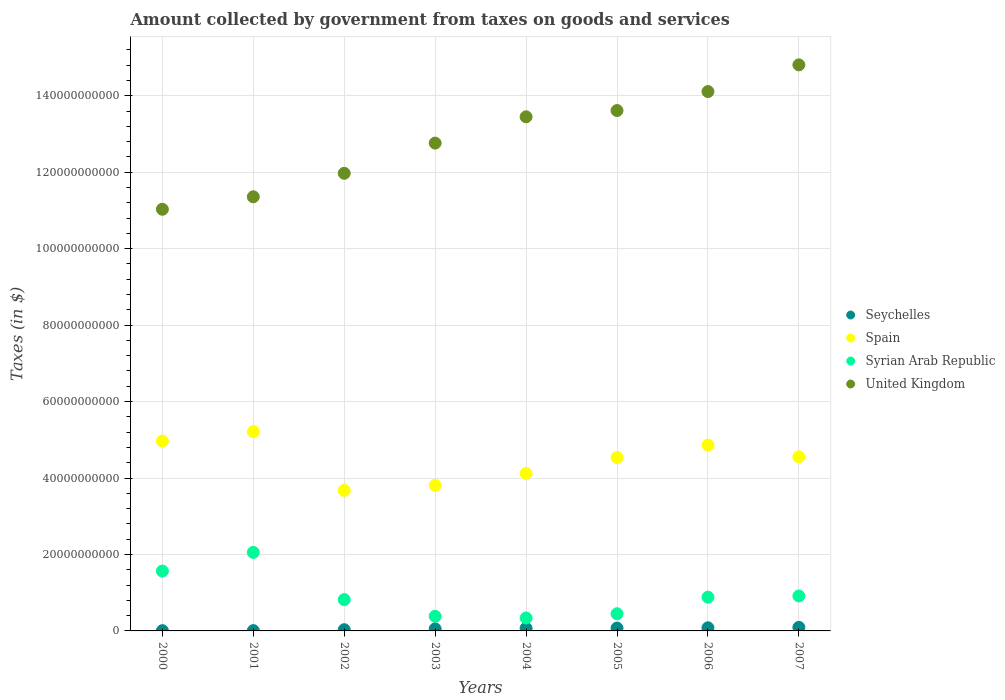How many different coloured dotlines are there?
Your answer should be compact. 4. Is the number of dotlines equal to the number of legend labels?
Offer a very short reply. Yes. What is the amount collected by government from taxes on goods and services in United Kingdom in 2005?
Keep it short and to the point. 1.36e+11. Across all years, what is the maximum amount collected by government from taxes on goods and services in Seychelles?
Your answer should be very brief. 9.26e+08. Across all years, what is the minimum amount collected by government from taxes on goods and services in United Kingdom?
Offer a very short reply. 1.10e+11. In which year was the amount collected by government from taxes on goods and services in United Kingdom maximum?
Your answer should be very brief. 2007. In which year was the amount collected by government from taxes on goods and services in Seychelles minimum?
Offer a terse response. 2000. What is the total amount collected by government from taxes on goods and services in Syrian Arab Republic in the graph?
Make the answer very short. 7.41e+1. What is the difference between the amount collected by government from taxes on goods and services in Spain in 2004 and that in 2006?
Offer a terse response. -7.43e+09. What is the difference between the amount collected by government from taxes on goods and services in Spain in 2005 and the amount collected by government from taxes on goods and services in Seychelles in 2001?
Your response must be concise. 4.53e+1. What is the average amount collected by government from taxes on goods and services in Spain per year?
Make the answer very short. 4.47e+1. In the year 2000, what is the difference between the amount collected by government from taxes on goods and services in Syrian Arab Republic and amount collected by government from taxes on goods and services in Spain?
Provide a succinct answer. -3.40e+1. In how many years, is the amount collected by government from taxes on goods and services in Spain greater than 20000000000 $?
Provide a succinct answer. 8. What is the ratio of the amount collected by government from taxes on goods and services in United Kingdom in 2000 to that in 2002?
Keep it short and to the point. 0.92. Is the amount collected by government from taxes on goods and services in United Kingdom in 2001 less than that in 2007?
Provide a short and direct response. Yes. Is the difference between the amount collected by government from taxes on goods and services in Syrian Arab Republic in 2001 and 2004 greater than the difference between the amount collected by government from taxes on goods and services in Spain in 2001 and 2004?
Make the answer very short. Yes. What is the difference between the highest and the second highest amount collected by government from taxes on goods and services in United Kingdom?
Your response must be concise. 6.98e+09. What is the difference between the highest and the lowest amount collected by government from taxes on goods and services in Seychelles?
Offer a terse response. 8.55e+08. Is it the case that in every year, the sum of the amount collected by government from taxes on goods and services in Seychelles and amount collected by government from taxes on goods and services in Syrian Arab Republic  is greater than the sum of amount collected by government from taxes on goods and services in Spain and amount collected by government from taxes on goods and services in United Kingdom?
Your answer should be very brief. No. Is it the case that in every year, the sum of the amount collected by government from taxes on goods and services in Seychelles and amount collected by government from taxes on goods and services in Spain  is greater than the amount collected by government from taxes on goods and services in United Kingdom?
Ensure brevity in your answer.  No. Does the amount collected by government from taxes on goods and services in Seychelles monotonically increase over the years?
Provide a succinct answer. Yes. Is the amount collected by government from taxes on goods and services in United Kingdom strictly greater than the amount collected by government from taxes on goods and services in Seychelles over the years?
Your answer should be compact. Yes. Is the amount collected by government from taxes on goods and services in Seychelles strictly less than the amount collected by government from taxes on goods and services in United Kingdom over the years?
Ensure brevity in your answer.  Yes. How many years are there in the graph?
Provide a short and direct response. 8. Are the values on the major ticks of Y-axis written in scientific E-notation?
Your answer should be very brief. No. Does the graph contain any zero values?
Offer a terse response. No. Does the graph contain grids?
Keep it short and to the point. Yes. How many legend labels are there?
Your answer should be compact. 4. How are the legend labels stacked?
Offer a terse response. Vertical. What is the title of the graph?
Give a very brief answer. Amount collected by government from taxes on goods and services. What is the label or title of the Y-axis?
Offer a terse response. Taxes (in $). What is the Taxes (in $) of Seychelles in 2000?
Provide a short and direct response. 7.17e+07. What is the Taxes (in $) of Spain in 2000?
Keep it short and to the point. 4.97e+1. What is the Taxes (in $) of Syrian Arab Republic in 2000?
Make the answer very short. 1.57e+1. What is the Taxes (in $) of United Kingdom in 2000?
Your answer should be compact. 1.10e+11. What is the Taxes (in $) of Seychelles in 2001?
Give a very brief answer. 8.16e+07. What is the Taxes (in $) in Spain in 2001?
Offer a terse response. 5.21e+1. What is the Taxes (in $) of Syrian Arab Republic in 2001?
Give a very brief answer. 2.05e+1. What is the Taxes (in $) of United Kingdom in 2001?
Provide a short and direct response. 1.14e+11. What is the Taxes (in $) of Seychelles in 2002?
Provide a succinct answer. 3.22e+08. What is the Taxes (in $) of Spain in 2002?
Keep it short and to the point. 3.68e+1. What is the Taxes (in $) in Syrian Arab Republic in 2002?
Make the answer very short. 8.19e+09. What is the Taxes (in $) in United Kingdom in 2002?
Your answer should be very brief. 1.20e+11. What is the Taxes (in $) in Seychelles in 2003?
Ensure brevity in your answer.  5.47e+08. What is the Taxes (in $) of Spain in 2003?
Provide a short and direct response. 3.81e+1. What is the Taxes (in $) in Syrian Arab Republic in 2003?
Your answer should be very brief. 3.82e+09. What is the Taxes (in $) in United Kingdom in 2003?
Your answer should be compact. 1.28e+11. What is the Taxes (in $) of Seychelles in 2004?
Keep it short and to the point. 6.87e+08. What is the Taxes (in $) of Spain in 2004?
Your response must be concise. 4.12e+1. What is the Taxes (in $) of Syrian Arab Republic in 2004?
Your response must be concise. 3.38e+09. What is the Taxes (in $) in United Kingdom in 2004?
Your answer should be compact. 1.34e+11. What is the Taxes (in $) in Seychelles in 2005?
Provide a short and direct response. 7.52e+08. What is the Taxes (in $) of Spain in 2005?
Make the answer very short. 4.54e+1. What is the Taxes (in $) of Syrian Arab Republic in 2005?
Your answer should be very brief. 4.49e+09. What is the Taxes (in $) in United Kingdom in 2005?
Offer a very short reply. 1.36e+11. What is the Taxes (in $) in Seychelles in 2006?
Keep it short and to the point. 8.21e+08. What is the Taxes (in $) of Spain in 2006?
Ensure brevity in your answer.  4.86e+1. What is the Taxes (in $) in Syrian Arab Republic in 2006?
Your answer should be very brief. 8.83e+09. What is the Taxes (in $) in United Kingdom in 2006?
Your answer should be very brief. 1.41e+11. What is the Taxes (in $) of Seychelles in 2007?
Provide a short and direct response. 9.26e+08. What is the Taxes (in $) of Spain in 2007?
Your answer should be compact. 4.55e+1. What is the Taxes (in $) of Syrian Arab Republic in 2007?
Make the answer very short. 9.14e+09. What is the Taxes (in $) in United Kingdom in 2007?
Provide a short and direct response. 1.48e+11. Across all years, what is the maximum Taxes (in $) in Seychelles?
Ensure brevity in your answer.  9.26e+08. Across all years, what is the maximum Taxes (in $) of Spain?
Your answer should be compact. 5.21e+1. Across all years, what is the maximum Taxes (in $) in Syrian Arab Republic?
Your answer should be compact. 2.05e+1. Across all years, what is the maximum Taxes (in $) of United Kingdom?
Give a very brief answer. 1.48e+11. Across all years, what is the minimum Taxes (in $) in Seychelles?
Your response must be concise. 7.17e+07. Across all years, what is the minimum Taxes (in $) in Spain?
Your answer should be compact. 3.68e+1. Across all years, what is the minimum Taxes (in $) in Syrian Arab Republic?
Offer a very short reply. 3.38e+09. Across all years, what is the minimum Taxes (in $) in United Kingdom?
Make the answer very short. 1.10e+11. What is the total Taxes (in $) in Seychelles in the graph?
Your answer should be compact. 4.21e+09. What is the total Taxes (in $) of Spain in the graph?
Make the answer very short. 3.57e+11. What is the total Taxes (in $) of Syrian Arab Republic in the graph?
Offer a terse response. 7.41e+1. What is the total Taxes (in $) of United Kingdom in the graph?
Your response must be concise. 1.03e+12. What is the difference between the Taxes (in $) in Seychelles in 2000 and that in 2001?
Provide a short and direct response. -9.90e+06. What is the difference between the Taxes (in $) of Spain in 2000 and that in 2001?
Offer a very short reply. -2.46e+09. What is the difference between the Taxes (in $) of Syrian Arab Republic in 2000 and that in 2001?
Provide a short and direct response. -4.89e+09. What is the difference between the Taxes (in $) of United Kingdom in 2000 and that in 2001?
Provide a succinct answer. -3.27e+09. What is the difference between the Taxes (in $) of Seychelles in 2000 and that in 2002?
Give a very brief answer. -2.50e+08. What is the difference between the Taxes (in $) in Spain in 2000 and that in 2002?
Offer a terse response. 1.29e+1. What is the difference between the Taxes (in $) in Syrian Arab Republic in 2000 and that in 2002?
Ensure brevity in your answer.  7.46e+09. What is the difference between the Taxes (in $) of United Kingdom in 2000 and that in 2002?
Your answer should be very brief. -9.41e+09. What is the difference between the Taxes (in $) of Seychelles in 2000 and that in 2003?
Offer a terse response. -4.75e+08. What is the difference between the Taxes (in $) in Spain in 2000 and that in 2003?
Offer a very short reply. 1.16e+1. What is the difference between the Taxes (in $) in Syrian Arab Republic in 2000 and that in 2003?
Provide a succinct answer. 1.18e+1. What is the difference between the Taxes (in $) of United Kingdom in 2000 and that in 2003?
Ensure brevity in your answer.  -1.73e+1. What is the difference between the Taxes (in $) in Seychelles in 2000 and that in 2004?
Make the answer very short. -6.15e+08. What is the difference between the Taxes (in $) of Spain in 2000 and that in 2004?
Your answer should be compact. 8.47e+09. What is the difference between the Taxes (in $) of Syrian Arab Republic in 2000 and that in 2004?
Your answer should be compact. 1.23e+1. What is the difference between the Taxes (in $) of United Kingdom in 2000 and that in 2004?
Your answer should be very brief. -2.42e+1. What is the difference between the Taxes (in $) in Seychelles in 2000 and that in 2005?
Your answer should be compact. -6.80e+08. What is the difference between the Taxes (in $) of Spain in 2000 and that in 2005?
Offer a very short reply. 4.29e+09. What is the difference between the Taxes (in $) in Syrian Arab Republic in 2000 and that in 2005?
Offer a terse response. 1.12e+1. What is the difference between the Taxes (in $) in United Kingdom in 2000 and that in 2005?
Make the answer very short. -2.58e+1. What is the difference between the Taxes (in $) in Seychelles in 2000 and that in 2006?
Make the answer very short. -7.49e+08. What is the difference between the Taxes (in $) in Spain in 2000 and that in 2006?
Provide a short and direct response. 1.04e+09. What is the difference between the Taxes (in $) in Syrian Arab Republic in 2000 and that in 2006?
Give a very brief answer. 6.82e+09. What is the difference between the Taxes (in $) in United Kingdom in 2000 and that in 2006?
Provide a succinct answer. -3.08e+1. What is the difference between the Taxes (in $) of Seychelles in 2000 and that in 2007?
Keep it short and to the point. -8.55e+08. What is the difference between the Taxes (in $) of Spain in 2000 and that in 2007?
Give a very brief answer. 4.12e+09. What is the difference between the Taxes (in $) of Syrian Arab Republic in 2000 and that in 2007?
Keep it short and to the point. 6.51e+09. What is the difference between the Taxes (in $) in United Kingdom in 2000 and that in 2007?
Ensure brevity in your answer.  -3.78e+1. What is the difference between the Taxes (in $) in Seychelles in 2001 and that in 2002?
Offer a terse response. -2.40e+08. What is the difference between the Taxes (in $) of Spain in 2001 and that in 2002?
Your response must be concise. 1.54e+1. What is the difference between the Taxes (in $) of Syrian Arab Republic in 2001 and that in 2002?
Make the answer very short. 1.24e+1. What is the difference between the Taxes (in $) in United Kingdom in 2001 and that in 2002?
Provide a succinct answer. -6.14e+09. What is the difference between the Taxes (in $) of Seychelles in 2001 and that in 2003?
Your answer should be very brief. -4.66e+08. What is the difference between the Taxes (in $) in Spain in 2001 and that in 2003?
Your answer should be very brief. 1.40e+1. What is the difference between the Taxes (in $) in Syrian Arab Republic in 2001 and that in 2003?
Offer a very short reply. 1.67e+1. What is the difference between the Taxes (in $) of United Kingdom in 2001 and that in 2003?
Offer a terse response. -1.40e+1. What is the difference between the Taxes (in $) in Seychelles in 2001 and that in 2004?
Your answer should be compact. -6.05e+08. What is the difference between the Taxes (in $) of Spain in 2001 and that in 2004?
Offer a terse response. 1.09e+1. What is the difference between the Taxes (in $) in Syrian Arab Republic in 2001 and that in 2004?
Make the answer very short. 1.72e+1. What is the difference between the Taxes (in $) in United Kingdom in 2001 and that in 2004?
Ensure brevity in your answer.  -2.09e+1. What is the difference between the Taxes (in $) of Seychelles in 2001 and that in 2005?
Your answer should be compact. -6.70e+08. What is the difference between the Taxes (in $) of Spain in 2001 and that in 2005?
Keep it short and to the point. 6.75e+09. What is the difference between the Taxes (in $) of Syrian Arab Republic in 2001 and that in 2005?
Your answer should be very brief. 1.61e+1. What is the difference between the Taxes (in $) of United Kingdom in 2001 and that in 2005?
Make the answer very short. -2.26e+1. What is the difference between the Taxes (in $) in Seychelles in 2001 and that in 2006?
Offer a very short reply. -7.39e+08. What is the difference between the Taxes (in $) of Spain in 2001 and that in 2006?
Your answer should be compact. 3.50e+09. What is the difference between the Taxes (in $) in Syrian Arab Republic in 2001 and that in 2006?
Make the answer very short. 1.17e+1. What is the difference between the Taxes (in $) in United Kingdom in 2001 and that in 2006?
Provide a short and direct response. -2.75e+1. What is the difference between the Taxes (in $) in Seychelles in 2001 and that in 2007?
Offer a terse response. -8.45e+08. What is the difference between the Taxes (in $) in Spain in 2001 and that in 2007?
Your response must be concise. 6.58e+09. What is the difference between the Taxes (in $) in Syrian Arab Republic in 2001 and that in 2007?
Offer a very short reply. 1.14e+1. What is the difference between the Taxes (in $) in United Kingdom in 2001 and that in 2007?
Provide a succinct answer. -3.45e+1. What is the difference between the Taxes (in $) of Seychelles in 2002 and that in 2003?
Offer a terse response. -2.26e+08. What is the difference between the Taxes (in $) in Spain in 2002 and that in 2003?
Offer a terse response. -1.32e+09. What is the difference between the Taxes (in $) in Syrian Arab Republic in 2002 and that in 2003?
Offer a very short reply. 4.37e+09. What is the difference between the Taxes (in $) of United Kingdom in 2002 and that in 2003?
Keep it short and to the point. -7.90e+09. What is the difference between the Taxes (in $) of Seychelles in 2002 and that in 2004?
Provide a short and direct response. -3.65e+08. What is the difference between the Taxes (in $) in Spain in 2002 and that in 2004?
Make the answer very short. -4.43e+09. What is the difference between the Taxes (in $) of Syrian Arab Republic in 2002 and that in 2004?
Offer a very short reply. 4.81e+09. What is the difference between the Taxes (in $) of United Kingdom in 2002 and that in 2004?
Offer a very short reply. -1.48e+1. What is the difference between the Taxes (in $) of Seychelles in 2002 and that in 2005?
Make the answer very short. -4.30e+08. What is the difference between the Taxes (in $) of Spain in 2002 and that in 2005?
Provide a succinct answer. -8.61e+09. What is the difference between the Taxes (in $) in Syrian Arab Republic in 2002 and that in 2005?
Offer a terse response. 3.70e+09. What is the difference between the Taxes (in $) in United Kingdom in 2002 and that in 2005?
Make the answer very short. -1.64e+1. What is the difference between the Taxes (in $) in Seychelles in 2002 and that in 2006?
Ensure brevity in your answer.  -4.99e+08. What is the difference between the Taxes (in $) in Spain in 2002 and that in 2006?
Provide a succinct answer. -1.19e+1. What is the difference between the Taxes (in $) of Syrian Arab Republic in 2002 and that in 2006?
Your answer should be compact. -6.39e+08. What is the difference between the Taxes (in $) of United Kingdom in 2002 and that in 2006?
Keep it short and to the point. -2.14e+1. What is the difference between the Taxes (in $) in Seychelles in 2002 and that in 2007?
Ensure brevity in your answer.  -6.05e+08. What is the difference between the Taxes (in $) of Spain in 2002 and that in 2007?
Offer a terse response. -8.78e+09. What is the difference between the Taxes (in $) in Syrian Arab Republic in 2002 and that in 2007?
Make the answer very short. -9.52e+08. What is the difference between the Taxes (in $) in United Kingdom in 2002 and that in 2007?
Provide a short and direct response. -2.84e+1. What is the difference between the Taxes (in $) in Seychelles in 2003 and that in 2004?
Your response must be concise. -1.40e+08. What is the difference between the Taxes (in $) of Spain in 2003 and that in 2004?
Provide a short and direct response. -3.11e+09. What is the difference between the Taxes (in $) in Syrian Arab Republic in 2003 and that in 2004?
Offer a very short reply. 4.42e+08. What is the difference between the Taxes (in $) in United Kingdom in 2003 and that in 2004?
Make the answer very short. -6.88e+09. What is the difference between the Taxes (in $) in Seychelles in 2003 and that in 2005?
Make the answer very short. -2.04e+08. What is the difference between the Taxes (in $) in Spain in 2003 and that in 2005?
Provide a short and direct response. -7.29e+09. What is the difference between the Taxes (in $) of Syrian Arab Republic in 2003 and that in 2005?
Give a very brief answer. -6.73e+08. What is the difference between the Taxes (in $) of United Kingdom in 2003 and that in 2005?
Make the answer very short. -8.52e+09. What is the difference between the Taxes (in $) in Seychelles in 2003 and that in 2006?
Your answer should be very brief. -2.74e+08. What is the difference between the Taxes (in $) of Spain in 2003 and that in 2006?
Your answer should be compact. -1.05e+1. What is the difference between the Taxes (in $) in Syrian Arab Republic in 2003 and that in 2006?
Provide a short and direct response. -5.01e+09. What is the difference between the Taxes (in $) in United Kingdom in 2003 and that in 2006?
Your answer should be very brief. -1.35e+1. What is the difference between the Taxes (in $) of Seychelles in 2003 and that in 2007?
Offer a terse response. -3.79e+08. What is the difference between the Taxes (in $) in Spain in 2003 and that in 2007?
Provide a short and direct response. -7.46e+09. What is the difference between the Taxes (in $) in Syrian Arab Republic in 2003 and that in 2007?
Your response must be concise. -5.32e+09. What is the difference between the Taxes (in $) in United Kingdom in 2003 and that in 2007?
Make the answer very short. -2.05e+1. What is the difference between the Taxes (in $) in Seychelles in 2004 and that in 2005?
Provide a succinct answer. -6.48e+07. What is the difference between the Taxes (in $) of Spain in 2004 and that in 2005?
Your response must be concise. -4.18e+09. What is the difference between the Taxes (in $) of Syrian Arab Republic in 2004 and that in 2005?
Your response must be concise. -1.12e+09. What is the difference between the Taxes (in $) in United Kingdom in 2004 and that in 2005?
Make the answer very short. -1.64e+09. What is the difference between the Taxes (in $) of Seychelles in 2004 and that in 2006?
Make the answer very short. -1.34e+08. What is the difference between the Taxes (in $) of Spain in 2004 and that in 2006?
Your answer should be compact. -7.43e+09. What is the difference between the Taxes (in $) in Syrian Arab Republic in 2004 and that in 2006?
Your response must be concise. -5.45e+09. What is the difference between the Taxes (in $) of United Kingdom in 2004 and that in 2006?
Offer a terse response. -6.60e+09. What is the difference between the Taxes (in $) of Seychelles in 2004 and that in 2007?
Offer a terse response. -2.40e+08. What is the difference between the Taxes (in $) of Spain in 2004 and that in 2007?
Offer a very short reply. -4.35e+09. What is the difference between the Taxes (in $) in Syrian Arab Republic in 2004 and that in 2007?
Keep it short and to the point. -5.77e+09. What is the difference between the Taxes (in $) in United Kingdom in 2004 and that in 2007?
Ensure brevity in your answer.  -1.36e+1. What is the difference between the Taxes (in $) in Seychelles in 2005 and that in 2006?
Ensure brevity in your answer.  -6.91e+07. What is the difference between the Taxes (in $) in Spain in 2005 and that in 2006?
Offer a very short reply. -3.25e+09. What is the difference between the Taxes (in $) of Syrian Arab Republic in 2005 and that in 2006?
Ensure brevity in your answer.  -4.34e+09. What is the difference between the Taxes (in $) of United Kingdom in 2005 and that in 2006?
Make the answer very short. -4.97e+09. What is the difference between the Taxes (in $) of Seychelles in 2005 and that in 2007?
Keep it short and to the point. -1.75e+08. What is the difference between the Taxes (in $) of Spain in 2005 and that in 2007?
Offer a very short reply. -1.71e+08. What is the difference between the Taxes (in $) in Syrian Arab Republic in 2005 and that in 2007?
Your answer should be very brief. -4.65e+09. What is the difference between the Taxes (in $) in United Kingdom in 2005 and that in 2007?
Your answer should be very brief. -1.20e+1. What is the difference between the Taxes (in $) of Seychelles in 2006 and that in 2007?
Offer a terse response. -1.06e+08. What is the difference between the Taxes (in $) in Spain in 2006 and that in 2007?
Your answer should be compact. 3.08e+09. What is the difference between the Taxes (in $) of Syrian Arab Republic in 2006 and that in 2007?
Your answer should be compact. -3.13e+08. What is the difference between the Taxes (in $) of United Kingdom in 2006 and that in 2007?
Ensure brevity in your answer.  -6.98e+09. What is the difference between the Taxes (in $) of Seychelles in 2000 and the Taxes (in $) of Spain in 2001?
Ensure brevity in your answer.  -5.21e+1. What is the difference between the Taxes (in $) of Seychelles in 2000 and the Taxes (in $) of Syrian Arab Republic in 2001?
Make the answer very short. -2.05e+1. What is the difference between the Taxes (in $) of Seychelles in 2000 and the Taxes (in $) of United Kingdom in 2001?
Ensure brevity in your answer.  -1.14e+11. What is the difference between the Taxes (in $) of Spain in 2000 and the Taxes (in $) of Syrian Arab Republic in 2001?
Ensure brevity in your answer.  2.91e+1. What is the difference between the Taxes (in $) in Spain in 2000 and the Taxes (in $) in United Kingdom in 2001?
Ensure brevity in your answer.  -6.39e+1. What is the difference between the Taxes (in $) of Syrian Arab Republic in 2000 and the Taxes (in $) of United Kingdom in 2001?
Offer a terse response. -9.79e+1. What is the difference between the Taxes (in $) of Seychelles in 2000 and the Taxes (in $) of Spain in 2002?
Make the answer very short. -3.67e+1. What is the difference between the Taxes (in $) in Seychelles in 2000 and the Taxes (in $) in Syrian Arab Republic in 2002?
Keep it short and to the point. -8.12e+09. What is the difference between the Taxes (in $) in Seychelles in 2000 and the Taxes (in $) in United Kingdom in 2002?
Offer a terse response. -1.20e+11. What is the difference between the Taxes (in $) in Spain in 2000 and the Taxes (in $) in Syrian Arab Republic in 2002?
Your answer should be very brief. 4.15e+1. What is the difference between the Taxes (in $) in Spain in 2000 and the Taxes (in $) in United Kingdom in 2002?
Give a very brief answer. -7.01e+1. What is the difference between the Taxes (in $) in Syrian Arab Republic in 2000 and the Taxes (in $) in United Kingdom in 2002?
Give a very brief answer. -1.04e+11. What is the difference between the Taxes (in $) of Seychelles in 2000 and the Taxes (in $) of Spain in 2003?
Your response must be concise. -3.80e+1. What is the difference between the Taxes (in $) in Seychelles in 2000 and the Taxes (in $) in Syrian Arab Republic in 2003?
Your answer should be very brief. -3.75e+09. What is the difference between the Taxes (in $) of Seychelles in 2000 and the Taxes (in $) of United Kingdom in 2003?
Your answer should be compact. -1.28e+11. What is the difference between the Taxes (in $) in Spain in 2000 and the Taxes (in $) in Syrian Arab Republic in 2003?
Ensure brevity in your answer.  4.58e+1. What is the difference between the Taxes (in $) of Spain in 2000 and the Taxes (in $) of United Kingdom in 2003?
Keep it short and to the point. -7.80e+1. What is the difference between the Taxes (in $) in Syrian Arab Republic in 2000 and the Taxes (in $) in United Kingdom in 2003?
Keep it short and to the point. -1.12e+11. What is the difference between the Taxes (in $) of Seychelles in 2000 and the Taxes (in $) of Spain in 2004?
Make the answer very short. -4.11e+1. What is the difference between the Taxes (in $) in Seychelles in 2000 and the Taxes (in $) in Syrian Arab Republic in 2004?
Offer a very short reply. -3.31e+09. What is the difference between the Taxes (in $) in Seychelles in 2000 and the Taxes (in $) in United Kingdom in 2004?
Ensure brevity in your answer.  -1.34e+11. What is the difference between the Taxes (in $) in Spain in 2000 and the Taxes (in $) in Syrian Arab Republic in 2004?
Offer a very short reply. 4.63e+1. What is the difference between the Taxes (in $) in Spain in 2000 and the Taxes (in $) in United Kingdom in 2004?
Ensure brevity in your answer.  -8.48e+1. What is the difference between the Taxes (in $) in Syrian Arab Republic in 2000 and the Taxes (in $) in United Kingdom in 2004?
Give a very brief answer. -1.19e+11. What is the difference between the Taxes (in $) of Seychelles in 2000 and the Taxes (in $) of Spain in 2005?
Keep it short and to the point. -4.53e+1. What is the difference between the Taxes (in $) of Seychelles in 2000 and the Taxes (in $) of Syrian Arab Republic in 2005?
Keep it short and to the point. -4.42e+09. What is the difference between the Taxes (in $) in Seychelles in 2000 and the Taxes (in $) in United Kingdom in 2005?
Offer a terse response. -1.36e+11. What is the difference between the Taxes (in $) of Spain in 2000 and the Taxes (in $) of Syrian Arab Republic in 2005?
Make the answer very short. 4.52e+1. What is the difference between the Taxes (in $) of Spain in 2000 and the Taxes (in $) of United Kingdom in 2005?
Your response must be concise. -8.65e+1. What is the difference between the Taxes (in $) in Syrian Arab Republic in 2000 and the Taxes (in $) in United Kingdom in 2005?
Provide a short and direct response. -1.20e+11. What is the difference between the Taxes (in $) in Seychelles in 2000 and the Taxes (in $) in Spain in 2006?
Your response must be concise. -4.86e+1. What is the difference between the Taxes (in $) in Seychelles in 2000 and the Taxes (in $) in Syrian Arab Republic in 2006?
Offer a terse response. -8.76e+09. What is the difference between the Taxes (in $) in Seychelles in 2000 and the Taxes (in $) in United Kingdom in 2006?
Provide a short and direct response. -1.41e+11. What is the difference between the Taxes (in $) in Spain in 2000 and the Taxes (in $) in Syrian Arab Republic in 2006?
Your response must be concise. 4.08e+1. What is the difference between the Taxes (in $) in Spain in 2000 and the Taxes (in $) in United Kingdom in 2006?
Your response must be concise. -9.14e+1. What is the difference between the Taxes (in $) of Syrian Arab Republic in 2000 and the Taxes (in $) of United Kingdom in 2006?
Keep it short and to the point. -1.25e+11. What is the difference between the Taxes (in $) in Seychelles in 2000 and the Taxes (in $) in Spain in 2007?
Your response must be concise. -4.55e+1. What is the difference between the Taxes (in $) of Seychelles in 2000 and the Taxes (in $) of Syrian Arab Republic in 2007?
Your answer should be compact. -9.07e+09. What is the difference between the Taxes (in $) of Seychelles in 2000 and the Taxes (in $) of United Kingdom in 2007?
Your answer should be very brief. -1.48e+11. What is the difference between the Taxes (in $) in Spain in 2000 and the Taxes (in $) in Syrian Arab Republic in 2007?
Provide a short and direct response. 4.05e+1. What is the difference between the Taxes (in $) of Spain in 2000 and the Taxes (in $) of United Kingdom in 2007?
Your answer should be compact. -9.84e+1. What is the difference between the Taxes (in $) in Syrian Arab Republic in 2000 and the Taxes (in $) in United Kingdom in 2007?
Your answer should be very brief. -1.32e+11. What is the difference between the Taxes (in $) in Seychelles in 2001 and the Taxes (in $) in Spain in 2002?
Your response must be concise. -3.67e+1. What is the difference between the Taxes (in $) of Seychelles in 2001 and the Taxes (in $) of Syrian Arab Republic in 2002?
Your answer should be compact. -8.11e+09. What is the difference between the Taxes (in $) in Seychelles in 2001 and the Taxes (in $) in United Kingdom in 2002?
Your answer should be very brief. -1.20e+11. What is the difference between the Taxes (in $) in Spain in 2001 and the Taxes (in $) in Syrian Arab Republic in 2002?
Give a very brief answer. 4.39e+1. What is the difference between the Taxes (in $) of Spain in 2001 and the Taxes (in $) of United Kingdom in 2002?
Offer a terse response. -6.76e+1. What is the difference between the Taxes (in $) in Syrian Arab Republic in 2001 and the Taxes (in $) in United Kingdom in 2002?
Your answer should be compact. -9.92e+1. What is the difference between the Taxes (in $) in Seychelles in 2001 and the Taxes (in $) in Spain in 2003?
Your answer should be compact. -3.80e+1. What is the difference between the Taxes (in $) of Seychelles in 2001 and the Taxes (in $) of Syrian Arab Republic in 2003?
Your answer should be compact. -3.74e+09. What is the difference between the Taxes (in $) in Seychelles in 2001 and the Taxes (in $) in United Kingdom in 2003?
Provide a short and direct response. -1.28e+11. What is the difference between the Taxes (in $) in Spain in 2001 and the Taxes (in $) in Syrian Arab Republic in 2003?
Keep it short and to the point. 4.83e+1. What is the difference between the Taxes (in $) of Spain in 2001 and the Taxes (in $) of United Kingdom in 2003?
Offer a terse response. -7.55e+1. What is the difference between the Taxes (in $) in Syrian Arab Republic in 2001 and the Taxes (in $) in United Kingdom in 2003?
Make the answer very short. -1.07e+11. What is the difference between the Taxes (in $) in Seychelles in 2001 and the Taxes (in $) in Spain in 2004?
Keep it short and to the point. -4.11e+1. What is the difference between the Taxes (in $) of Seychelles in 2001 and the Taxes (in $) of Syrian Arab Republic in 2004?
Give a very brief answer. -3.30e+09. What is the difference between the Taxes (in $) in Seychelles in 2001 and the Taxes (in $) in United Kingdom in 2004?
Offer a terse response. -1.34e+11. What is the difference between the Taxes (in $) in Spain in 2001 and the Taxes (in $) in Syrian Arab Republic in 2004?
Your answer should be very brief. 4.87e+1. What is the difference between the Taxes (in $) in Spain in 2001 and the Taxes (in $) in United Kingdom in 2004?
Give a very brief answer. -8.24e+1. What is the difference between the Taxes (in $) of Syrian Arab Republic in 2001 and the Taxes (in $) of United Kingdom in 2004?
Your answer should be compact. -1.14e+11. What is the difference between the Taxes (in $) in Seychelles in 2001 and the Taxes (in $) in Spain in 2005?
Keep it short and to the point. -4.53e+1. What is the difference between the Taxes (in $) in Seychelles in 2001 and the Taxes (in $) in Syrian Arab Republic in 2005?
Offer a very short reply. -4.41e+09. What is the difference between the Taxes (in $) in Seychelles in 2001 and the Taxes (in $) in United Kingdom in 2005?
Provide a succinct answer. -1.36e+11. What is the difference between the Taxes (in $) of Spain in 2001 and the Taxes (in $) of Syrian Arab Republic in 2005?
Provide a succinct answer. 4.76e+1. What is the difference between the Taxes (in $) of Spain in 2001 and the Taxes (in $) of United Kingdom in 2005?
Your answer should be compact. -8.40e+1. What is the difference between the Taxes (in $) of Syrian Arab Republic in 2001 and the Taxes (in $) of United Kingdom in 2005?
Offer a terse response. -1.16e+11. What is the difference between the Taxes (in $) of Seychelles in 2001 and the Taxes (in $) of Spain in 2006?
Your answer should be compact. -4.85e+1. What is the difference between the Taxes (in $) of Seychelles in 2001 and the Taxes (in $) of Syrian Arab Republic in 2006?
Provide a succinct answer. -8.75e+09. What is the difference between the Taxes (in $) of Seychelles in 2001 and the Taxes (in $) of United Kingdom in 2006?
Your answer should be very brief. -1.41e+11. What is the difference between the Taxes (in $) in Spain in 2001 and the Taxes (in $) in Syrian Arab Republic in 2006?
Your answer should be very brief. 4.33e+1. What is the difference between the Taxes (in $) of Spain in 2001 and the Taxes (in $) of United Kingdom in 2006?
Your response must be concise. -8.90e+1. What is the difference between the Taxes (in $) in Syrian Arab Republic in 2001 and the Taxes (in $) in United Kingdom in 2006?
Provide a succinct answer. -1.21e+11. What is the difference between the Taxes (in $) in Seychelles in 2001 and the Taxes (in $) in Spain in 2007?
Your response must be concise. -4.55e+1. What is the difference between the Taxes (in $) in Seychelles in 2001 and the Taxes (in $) in Syrian Arab Republic in 2007?
Keep it short and to the point. -9.06e+09. What is the difference between the Taxes (in $) in Seychelles in 2001 and the Taxes (in $) in United Kingdom in 2007?
Offer a very short reply. -1.48e+11. What is the difference between the Taxes (in $) in Spain in 2001 and the Taxes (in $) in Syrian Arab Republic in 2007?
Keep it short and to the point. 4.30e+1. What is the difference between the Taxes (in $) in Spain in 2001 and the Taxes (in $) in United Kingdom in 2007?
Make the answer very short. -9.60e+1. What is the difference between the Taxes (in $) of Syrian Arab Republic in 2001 and the Taxes (in $) of United Kingdom in 2007?
Your answer should be compact. -1.28e+11. What is the difference between the Taxes (in $) of Seychelles in 2002 and the Taxes (in $) of Spain in 2003?
Offer a terse response. -3.78e+1. What is the difference between the Taxes (in $) of Seychelles in 2002 and the Taxes (in $) of Syrian Arab Republic in 2003?
Your answer should be compact. -3.50e+09. What is the difference between the Taxes (in $) in Seychelles in 2002 and the Taxes (in $) in United Kingdom in 2003?
Your response must be concise. -1.27e+11. What is the difference between the Taxes (in $) in Spain in 2002 and the Taxes (in $) in Syrian Arab Republic in 2003?
Provide a succinct answer. 3.29e+1. What is the difference between the Taxes (in $) of Spain in 2002 and the Taxes (in $) of United Kingdom in 2003?
Make the answer very short. -9.08e+1. What is the difference between the Taxes (in $) of Syrian Arab Republic in 2002 and the Taxes (in $) of United Kingdom in 2003?
Keep it short and to the point. -1.19e+11. What is the difference between the Taxes (in $) in Seychelles in 2002 and the Taxes (in $) in Spain in 2004?
Your response must be concise. -4.09e+1. What is the difference between the Taxes (in $) in Seychelles in 2002 and the Taxes (in $) in Syrian Arab Republic in 2004?
Keep it short and to the point. -3.06e+09. What is the difference between the Taxes (in $) of Seychelles in 2002 and the Taxes (in $) of United Kingdom in 2004?
Make the answer very short. -1.34e+11. What is the difference between the Taxes (in $) of Spain in 2002 and the Taxes (in $) of Syrian Arab Republic in 2004?
Offer a very short reply. 3.34e+1. What is the difference between the Taxes (in $) in Spain in 2002 and the Taxes (in $) in United Kingdom in 2004?
Ensure brevity in your answer.  -9.77e+1. What is the difference between the Taxes (in $) in Syrian Arab Republic in 2002 and the Taxes (in $) in United Kingdom in 2004?
Your response must be concise. -1.26e+11. What is the difference between the Taxes (in $) of Seychelles in 2002 and the Taxes (in $) of Spain in 2005?
Keep it short and to the point. -4.51e+1. What is the difference between the Taxes (in $) in Seychelles in 2002 and the Taxes (in $) in Syrian Arab Republic in 2005?
Make the answer very short. -4.17e+09. What is the difference between the Taxes (in $) of Seychelles in 2002 and the Taxes (in $) of United Kingdom in 2005?
Give a very brief answer. -1.36e+11. What is the difference between the Taxes (in $) in Spain in 2002 and the Taxes (in $) in Syrian Arab Republic in 2005?
Give a very brief answer. 3.23e+1. What is the difference between the Taxes (in $) in Spain in 2002 and the Taxes (in $) in United Kingdom in 2005?
Keep it short and to the point. -9.94e+1. What is the difference between the Taxes (in $) of Syrian Arab Republic in 2002 and the Taxes (in $) of United Kingdom in 2005?
Your answer should be compact. -1.28e+11. What is the difference between the Taxes (in $) in Seychelles in 2002 and the Taxes (in $) in Spain in 2006?
Provide a short and direct response. -4.83e+1. What is the difference between the Taxes (in $) in Seychelles in 2002 and the Taxes (in $) in Syrian Arab Republic in 2006?
Your response must be concise. -8.51e+09. What is the difference between the Taxes (in $) of Seychelles in 2002 and the Taxes (in $) of United Kingdom in 2006?
Provide a short and direct response. -1.41e+11. What is the difference between the Taxes (in $) of Spain in 2002 and the Taxes (in $) of Syrian Arab Republic in 2006?
Give a very brief answer. 2.79e+1. What is the difference between the Taxes (in $) of Spain in 2002 and the Taxes (in $) of United Kingdom in 2006?
Make the answer very short. -1.04e+11. What is the difference between the Taxes (in $) of Syrian Arab Republic in 2002 and the Taxes (in $) of United Kingdom in 2006?
Offer a terse response. -1.33e+11. What is the difference between the Taxes (in $) of Seychelles in 2002 and the Taxes (in $) of Spain in 2007?
Offer a terse response. -4.52e+1. What is the difference between the Taxes (in $) in Seychelles in 2002 and the Taxes (in $) in Syrian Arab Republic in 2007?
Your answer should be very brief. -8.82e+09. What is the difference between the Taxes (in $) in Seychelles in 2002 and the Taxes (in $) in United Kingdom in 2007?
Keep it short and to the point. -1.48e+11. What is the difference between the Taxes (in $) of Spain in 2002 and the Taxes (in $) of Syrian Arab Republic in 2007?
Your answer should be compact. 2.76e+1. What is the difference between the Taxes (in $) in Spain in 2002 and the Taxes (in $) in United Kingdom in 2007?
Ensure brevity in your answer.  -1.11e+11. What is the difference between the Taxes (in $) of Syrian Arab Republic in 2002 and the Taxes (in $) of United Kingdom in 2007?
Give a very brief answer. -1.40e+11. What is the difference between the Taxes (in $) of Seychelles in 2003 and the Taxes (in $) of Spain in 2004?
Make the answer very short. -4.06e+1. What is the difference between the Taxes (in $) in Seychelles in 2003 and the Taxes (in $) in Syrian Arab Republic in 2004?
Give a very brief answer. -2.83e+09. What is the difference between the Taxes (in $) in Seychelles in 2003 and the Taxes (in $) in United Kingdom in 2004?
Your answer should be very brief. -1.34e+11. What is the difference between the Taxes (in $) in Spain in 2003 and the Taxes (in $) in Syrian Arab Republic in 2004?
Offer a terse response. 3.47e+1. What is the difference between the Taxes (in $) of Spain in 2003 and the Taxes (in $) of United Kingdom in 2004?
Give a very brief answer. -9.64e+1. What is the difference between the Taxes (in $) of Syrian Arab Republic in 2003 and the Taxes (in $) of United Kingdom in 2004?
Provide a short and direct response. -1.31e+11. What is the difference between the Taxes (in $) of Seychelles in 2003 and the Taxes (in $) of Spain in 2005?
Keep it short and to the point. -4.48e+1. What is the difference between the Taxes (in $) of Seychelles in 2003 and the Taxes (in $) of Syrian Arab Republic in 2005?
Give a very brief answer. -3.95e+09. What is the difference between the Taxes (in $) of Seychelles in 2003 and the Taxes (in $) of United Kingdom in 2005?
Provide a short and direct response. -1.36e+11. What is the difference between the Taxes (in $) of Spain in 2003 and the Taxes (in $) of Syrian Arab Republic in 2005?
Keep it short and to the point. 3.36e+1. What is the difference between the Taxes (in $) in Spain in 2003 and the Taxes (in $) in United Kingdom in 2005?
Your answer should be very brief. -9.80e+1. What is the difference between the Taxes (in $) in Syrian Arab Republic in 2003 and the Taxes (in $) in United Kingdom in 2005?
Keep it short and to the point. -1.32e+11. What is the difference between the Taxes (in $) of Seychelles in 2003 and the Taxes (in $) of Spain in 2006?
Offer a very short reply. -4.81e+1. What is the difference between the Taxes (in $) in Seychelles in 2003 and the Taxes (in $) in Syrian Arab Republic in 2006?
Offer a terse response. -8.28e+09. What is the difference between the Taxes (in $) of Seychelles in 2003 and the Taxes (in $) of United Kingdom in 2006?
Your answer should be very brief. -1.41e+11. What is the difference between the Taxes (in $) of Spain in 2003 and the Taxes (in $) of Syrian Arab Republic in 2006?
Your response must be concise. 2.93e+1. What is the difference between the Taxes (in $) of Spain in 2003 and the Taxes (in $) of United Kingdom in 2006?
Provide a short and direct response. -1.03e+11. What is the difference between the Taxes (in $) in Syrian Arab Republic in 2003 and the Taxes (in $) in United Kingdom in 2006?
Give a very brief answer. -1.37e+11. What is the difference between the Taxes (in $) of Seychelles in 2003 and the Taxes (in $) of Spain in 2007?
Offer a terse response. -4.50e+1. What is the difference between the Taxes (in $) in Seychelles in 2003 and the Taxes (in $) in Syrian Arab Republic in 2007?
Ensure brevity in your answer.  -8.60e+09. What is the difference between the Taxes (in $) in Seychelles in 2003 and the Taxes (in $) in United Kingdom in 2007?
Keep it short and to the point. -1.48e+11. What is the difference between the Taxes (in $) in Spain in 2003 and the Taxes (in $) in Syrian Arab Republic in 2007?
Offer a very short reply. 2.89e+1. What is the difference between the Taxes (in $) of Spain in 2003 and the Taxes (in $) of United Kingdom in 2007?
Offer a very short reply. -1.10e+11. What is the difference between the Taxes (in $) of Syrian Arab Republic in 2003 and the Taxes (in $) of United Kingdom in 2007?
Offer a terse response. -1.44e+11. What is the difference between the Taxes (in $) in Seychelles in 2004 and the Taxes (in $) in Spain in 2005?
Your response must be concise. -4.47e+1. What is the difference between the Taxes (in $) in Seychelles in 2004 and the Taxes (in $) in Syrian Arab Republic in 2005?
Your answer should be very brief. -3.81e+09. What is the difference between the Taxes (in $) in Seychelles in 2004 and the Taxes (in $) in United Kingdom in 2005?
Provide a short and direct response. -1.35e+11. What is the difference between the Taxes (in $) in Spain in 2004 and the Taxes (in $) in Syrian Arab Republic in 2005?
Ensure brevity in your answer.  3.67e+1. What is the difference between the Taxes (in $) of Spain in 2004 and the Taxes (in $) of United Kingdom in 2005?
Provide a succinct answer. -9.49e+1. What is the difference between the Taxes (in $) of Syrian Arab Republic in 2004 and the Taxes (in $) of United Kingdom in 2005?
Offer a terse response. -1.33e+11. What is the difference between the Taxes (in $) of Seychelles in 2004 and the Taxes (in $) of Spain in 2006?
Make the answer very short. -4.79e+1. What is the difference between the Taxes (in $) in Seychelles in 2004 and the Taxes (in $) in Syrian Arab Republic in 2006?
Your answer should be very brief. -8.15e+09. What is the difference between the Taxes (in $) of Seychelles in 2004 and the Taxes (in $) of United Kingdom in 2006?
Provide a short and direct response. -1.40e+11. What is the difference between the Taxes (in $) of Spain in 2004 and the Taxes (in $) of Syrian Arab Republic in 2006?
Your answer should be compact. 3.24e+1. What is the difference between the Taxes (in $) of Spain in 2004 and the Taxes (in $) of United Kingdom in 2006?
Provide a short and direct response. -9.99e+1. What is the difference between the Taxes (in $) of Syrian Arab Republic in 2004 and the Taxes (in $) of United Kingdom in 2006?
Make the answer very short. -1.38e+11. What is the difference between the Taxes (in $) of Seychelles in 2004 and the Taxes (in $) of Spain in 2007?
Make the answer very short. -4.49e+1. What is the difference between the Taxes (in $) in Seychelles in 2004 and the Taxes (in $) in Syrian Arab Republic in 2007?
Ensure brevity in your answer.  -8.46e+09. What is the difference between the Taxes (in $) of Seychelles in 2004 and the Taxes (in $) of United Kingdom in 2007?
Make the answer very short. -1.47e+11. What is the difference between the Taxes (in $) in Spain in 2004 and the Taxes (in $) in Syrian Arab Republic in 2007?
Offer a very short reply. 3.21e+1. What is the difference between the Taxes (in $) in Spain in 2004 and the Taxes (in $) in United Kingdom in 2007?
Keep it short and to the point. -1.07e+11. What is the difference between the Taxes (in $) of Syrian Arab Republic in 2004 and the Taxes (in $) of United Kingdom in 2007?
Your response must be concise. -1.45e+11. What is the difference between the Taxes (in $) in Seychelles in 2005 and the Taxes (in $) in Spain in 2006?
Give a very brief answer. -4.79e+1. What is the difference between the Taxes (in $) in Seychelles in 2005 and the Taxes (in $) in Syrian Arab Republic in 2006?
Keep it short and to the point. -8.08e+09. What is the difference between the Taxes (in $) in Seychelles in 2005 and the Taxes (in $) in United Kingdom in 2006?
Provide a succinct answer. -1.40e+11. What is the difference between the Taxes (in $) of Spain in 2005 and the Taxes (in $) of Syrian Arab Republic in 2006?
Keep it short and to the point. 3.65e+1. What is the difference between the Taxes (in $) of Spain in 2005 and the Taxes (in $) of United Kingdom in 2006?
Provide a short and direct response. -9.57e+1. What is the difference between the Taxes (in $) of Syrian Arab Republic in 2005 and the Taxes (in $) of United Kingdom in 2006?
Offer a very short reply. -1.37e+11. What is the difference between the Taxes (in $) in Seychelles in 2005 and the Taxes (in $) in Spain in 2007?
Make the answer very short. -4.48e+1. What is the difference between the Taxes (in $) of Seychelles in 2005 and the Taxes (in $) of Syrian Arab Republic in 2007?
Ensure brevity in your answer.  -8.39e+09. What is the difference between the Taxes (in $) in Seychelles in 2005 and the Taxes (in $) in United Kingdom in 2007?
Provide a short and direct response. -1.47e+11. What is the difference between the Taxes (in $) of Spain in 2005 and the Taxes (in $) of Syrian Arab Republic in 2007?
Your answer should be compact. 3.62e+1. What is the difference between the Taxes (in $) in Spain in 2005 and the Taxes (in $) in United Kingdom in 2007?
Your response must be concise. -1.03e+11. What is the difference between the Taxes (in $) in Syrian Arab Republic in 2005 and the Taxes (in $) in United Kingdom in 2007?
Provide a short and direct response. -1.44e+11. What is the difference between the Taxes (in $) in Seychelles in 2006 and the Taxes (in $) in Spain in 2007?
Offer a terse response. -4.47e+1. What is the difference between the Taxes (in $) of Seychelles in 2006 and the Taxes (in $) of Syrian Arab Republic in 2007?
Offer a very short reply. -8.32e+09. What is the difference between the Taxes (in $) in Seychelles in 2006 and the Taxes (in $) in United Kingdom in 2007?
Make the answer very short. -1.47e+11. What is the difference between the Taxes (in $) of Spain in 2006 and the Taxes (in $) of Syrian Arab Republic in 2007?
Offer a very short reply. 3.95e+1. What is the difference between the Taxes (in $) of Spain in 2006 and the Taxes (in $) of United Kingdom in 2007?
Your response must be concise. -9.95e+1. What is the difference between the Taxes (in $) in Syrian Arab Republic in 2006 and the Taxes (in $) in United Kingdom in 2007?
Provide a short and direct response. -1.39e+11. What is the average Taxes (in $) in Seychelles per year?
Give a very brief answer. 5.26e+08. What is the average Taxes (in $) of Spain per year?
Provide a short and direct response. 4.47e+1. What is the average Taxes (in $) in Syrian Arab Republic per year?
Your answer should be very brief. 9.26e+09. What is the average Taxes (in $) in United Kingdom per year?
Your answer should be very brief. 1.29e+11. In the year 2000, what is the difference between the Taxes (in $) of Seychelles and Taxes (in $) of Spain?
Give a very brief answer. -4.96e+1. In the year 2000, what is the difference between the Taxes (in $) of Seychelles and Taxes (in $) of Syrian Arab Republic?
Your answer should be very brief. -1.56e+1. In the year 2000, what is the difference between the Taxes (in $) of Seychelles and Taxes (in $) of United Kingdom?
Keep it short and to the point. -1.10e+11. In the year 2000, what is the difference between the Taxes (in $) in Spain and Taxes (in $) in Syrian Arab Republic?
Your answer should be very brief. 3.40e+1. In the year 2000, what is the difference between the Taxes (in $) in Spain and Taxes (in $) in United Kingdom?
Give a very brief answer. -6.06e+1. In the year 2000, what is the difference between the Taxes (in $) of Syrian Arab Republic and Taxes (in $) of United Kingdom?
Your response must be concise. -9.47e+1. In the year 2001, what is the difference between the Taxes (in $) in Seychelles and Taxes (in $) in Spain?
Your response must be concise. -5.20e+1. In the year 2001, what is the difference between the Taxes (in $) in Seychelles and Taxes (in $) in Syrian Arab Republic?
Provide a short and direct response. -2.05e+1. In the year 2001, what is the difference between the Taxes (in $) of Seychelles and Taxes (in $) of United Kingdom?
Offer a terse response. -1.13e+11. In the year 2001, what is the difference between the Taxes (in $) of Spain and Taxes (in $) of Syrian Arab Republic?
Your response must be concise. 3.16e+1. In the year 2001, what is the difference between the Taxes (in $) of Spain and Taxes (in $) of United Kingdom?
Your answer should be compact. -6.15e+1. In the year 2001, what is the difference between the Taxes (in $) in Syrian Arab Republic and Taxes (in $) in United Kingdom?
Your response must be concise. -9.30e+1. In the year 2002, what is the difference between the Taxes (in $) of Seychelles and Taxes (in $) of Spain?
Provide a short and direct response. -3.64e+1. In the year 2002, what is the difference between the Taxes (in $) in Seychelles and Taxes (in $) in Syrian Arab Republic?
Give a very brief answer. -7.87e+09. In the year 2002, what is the difference between the Taxes (in $) of Seychelles and Taxes (in $) of United Kingdom?
Provide a short and direct response. -1.19e+11. In the year 2002, what is the difference between the Taxes (in $) of Spain and Taxes (in $) of Syrian Arab Republic?
Your answer should be very brief. 2.86e+1. In the year 2002, what is the difference between the Taxes (in $) of Spain and Taxes (in $) of United Kingdom?
Offer a terse response. -8.30e+1. In the year 2002, what is the difference between the Taxes (in $) in Syrian Arab Republic and Taxes (in $) in United Kingdom?
Provide a succinct answer. -1.12e+11. In the year 2003, what is the difference between the Taxes (in $) of Seychelles and Taxes (in $) of Spain?
Provide a short and direct response. -3.75e+1. In the year 2003, what is the difference between the Taxes (in $) of Seychelles and Taxes (in $) of Syrian Arab Republic?
Your answer should be very brief. -3.27e+09. In the year 2003, what is the difference between the Taxes (in $) in Seychelles and Taxes (in $) in United Kingdom?
Provide a short and direct response. -1.27e+11. In the year 2003, what is the difference between the Taxes (in $) in Spain and Taxes (in $) in Syrian Arab Republic?
Provide a short and direct response. 3.43e+1. In the year 2003, what is the difference between the Taxes (in $) in Spain and Taxes (in $) in United Kingdom?
Offer a very short reply. -8.95e+1. In the year 2003, what is the difference between the Taxes (in $) of Syrian Arab Republic and Taxes (in $) of United Kingdom?
Give a very brief answer. -1.24e+11. In the year 2004, what is the difference between the Taxes (in $) in Seychelles and Taxes (in $) in Spain?
Your answer should be very brief. -4.05e+1. In the year 2004, what is the difference between the Taxes (in $) in Seychelles and Taxes (in $) in Syrian Arab Republic?
Your answer should be compact. -2.69e+09. In the year 2004, what is the difference between the Taxes (in $) of Seychelles and Taxes (in $) of United Kingdom?
Offer a very short reply. -1.34e+11. In the year 2004, what is the difference between the Taxes (in $) of Spain and Taxes (in $) of Syrian Arab Republic?
Offer a very short reply. 3.78e+1. In the year 2004, what is the difference between the Taxes (in $) of Spain and Taxes (in $) of United Kingdom?
Your response must be concise. -9.33e+1. In the year 2004, what is the difference between the Taxes (in $) in Syrian Arab Republic and Taxes (in $) in United Kingdom?
Provide a short and direct response. -1.31e+11. In the year 2005, what is the difference between the Taxes (in $) of Seychelles and Taxes (in $) of Spain?
Your answer should be very brief. -4.46e+1. In the year 2005, what is the difference between the Taxes (in $) of Seychelles and Taxes (in $) of Syrian Arab Republic?
Your response must be concise. -3.74e+09. In the year 2005, what is the difference between the Taxes (in $) of Seychelles and Taxes (in $) of United Kingdom?
Your answer should be very brief. -1.35e+11. In the year 2005, what is the difference between the Taxes (in $) of Spain and Taxes (in $) of Syrian Arab Republic?
Keep it short and to the point. 4.09e+1. In the year 2005, what is the difference between the Taxes (in $) of Spain and Taxes (in $) of United Kingdom?
Offer a very short reply. -9.08e+1. In the year 2005, what is the difference between the Taxes (in $) of Syrian Arab Republic and Taxes (in $) of United Kingdom?
Keep it short and to the point. -1.32e+11. In the year 2006, what is the difference between the Taxes (in $) of Seychelles and Taxes (in $) of Spain?
Ensure brevity in your answer.  -4.78e+1. In the year 2006, what is the difference between the Taxes (in $) of Seychelles and Taxes (in $) of Syrian Arab Republic?
Keep it short and to the point. -8.01e+09. In the year 2006, what is the difference between the Taxes (in $) in Seychelles and Taxes (in $) in United Kingdom?
Your response must be concise. -1.40e+11. In the year 2006, what is the difference between the Taxes (in $) of Spain and Taxes (in $) of Syrian Arab Republic?
Your response must be concise. 3.98e+1. In the year 2006, what is the difference between the Taxes (in $) of Spain and Taxes (in $) of United Kingdom?
Your answer should be very brief. -9.25e+1. In the year 2006, what is the difference between the Taxes (in $) of Syrian Arab Republic and Taxes (in $) of United Kingdom?
Your response must be concise. -1.32e+11. In the year 2007, what is the difference between the Taxes (in $) of Seychelles and Taxes (in $) of Spain?
Ensure brevity in your answer.  -4.46e+1. In the year 2007, what is the difference between the Taxes (in $) in Seychelles and Taxes (in $) in Syrian Arab Republic?
Your answer should be compact. -8.22e+09. In the year 2007, what is the difference between the Taxes (in $) of Seychelles and Taxes (in $) of United Kingdom?
Your answer should be very brief. -1.47e+11. In the year 2007, what is the difference between the Taxes (in $) in Spain and Taxes (in $) in Syrian Arab Republic?
Keep it short and to the point. 3.64e+1. In the year 2007, what is the difference between the Taxes (in $) of Spain and Taxes (in $) of United Kingdom?
Offer a terse response. -1.03e+11. In the year 2007, what is the difference between the Taxes (in $) in Syrian Arab Republic and Taxes (in $) in United Kingdom?
Make the answer very short. -1.39e+11. What is the ratio of the Taxes (in $) of Seychelles in 2000 to that in 2001?
Make the answer very short. 0.88. What is the ratio of the Taxes (in $) in Spain in 2000 to that in 2001?
Ensure brevity in your answer.  0.95. What is the ratio of the Taxes (in $) of Syrian Arab Republic in 2000 to that in 2001?
Make the answer very short. 0.76. What is the ratio of the Taxes (in $) in United Kingdom in 2000 to that in 2001?
Provide a succinct answer. 0.97. What is the ratio of the Taxes (in $) of Seychelles in 2000 to that in 2002?
Give a very brief answer. 0.22. What is the ratio of the Taxes (in $) of Spain in 2000 to that in 2002?
Offer a very short reply. 1.35. What is the ratio of the Taxes (in $) of Syrian Arab Republic in 2000 to that in 2002?
Provide a short and direct response. 1.91. What is the ratio of the Taxes (in $) in United Kingdom in 2000 to that in 2002?
Keep it short and to the point. 0.92. What is the ratio of the Taxes (in $) in Seychelles in 2000 to that in 2003?
Give a very brief answer. 0.13. What is the ratio of the Taxes (in $) in Spain in 2000 to that in 2003?
Ensure brevity in your answer.  1.3. What is the ratio of the Taxes (in $) of Syrian Arab Republic in 2000 to that in 2003?
Provide a short and direct response. 4.1. What is the ratio of the Taxes (in $) of United Kingdom in 2000 to that in 2003?
Offer a very short reply. 0.86. What is the ratio of the Taxes (in $) in Seychelles in 2000 to that in 2004?
Ensure brevity in your answer.  0.1. What is the ratio of the Taxes (in $) of Spain in 2000 to that in 2004?
Offer a very short reply. 1.21. What is the ratio of the Taxes (in $) of Syrian Arab Republic in 2000 to that in 2004?
Your response must be concise. 4.63. What is the ratio of the Taxes (in $) in United Kingdom in 2000 to that in 2004?
Offer a very short reply. 0.82. What is the ratio of the Taxes (in $) of Seychelles in 2000 to that in 2005?
Provide a succinct answer. 0.1. What is the ratio of the Taxes (in $) of Spain in 2000 to that in 2005?
Offer a very short reply. 1.09. What is the ratio of the Taxes (in $) in Syrian Arab Republic in 2000 to that in 2005?
Your answer should be compact. 3.48. What is the ratio of the Taxes (in $) in United Kingdom in 2000 to that in 2005?
Ensure brevity in your answer.  0.81. What is the ratio of the Taxes (in $) of Seychelles in 2000 to that in 2006?
Provide a succinct answer. 0.09. What is the ratio of the Taxes (in $) of Spain in 2000 to that in 2006?
Your response must be concise. 1.02. What is the ratio of the Taxes (in $) of Syrian Arab Republic in 2000 to that in 2006?
Your response must be concise. 1.77. What is the ratio of the Taxes (in $) of United Kingdom in 2000 to that in 2006?
Your response must be concise. 0.78. What is the ratio of the Taxes (in $) in Seychelles in 2000 to that in 2007?
Provide a short and direct response. 0.08. What is the ratio of the Taxes (in $) of Spain in 2000 to that in 2007?
Your answer should be compact. 1.09. What is the ratio of the Taxes (in $) of Syrian Arab Republic in 2000 to that in 2007?
Your answer should be compact. 1.71. What is the ratio of the Taxes (in $) in United Kingdom in 2000 to that in 2007?
Your answer should be compact. 0.74. What is the ratio of the Taxes (in $) of Seychelles in 2001 to that in 2002?
Keep it short and to the point. 0.25. What is the ratio of the Taxes (in $) in Spain in 2001 to that in 2002?
Offer a terse response. 1.42. What is the ratio of the Taxes (in $) of Syrian Arab Republic in 2001 to that in 2002?
Keep it short and to the point. 2.51. What is the ratio of the Taxes (in $) in United Kingdom in 2001 to that in 2002?
Give a very brief answer. 0.95. What is the ratio of the Taxes (in $) of Seychelles in 2001 to that in 2003?
Keep it short and to the point. 0.15. What is the ratio of the Taxes (in $) of Spain in 2001 to that in 2003?
Your response must be concise. 1.37. What is the ratio of the Taxes (in $) of Syrian Arab Republic in 2001 to that in 2003?
Ensure brevity in your answer.  5.38. What is the ratio of the Taxes (in $) of United Kingdom in 2001 to that in 2003?
Your response must be concise. 0.89. What is the ratio of the Taxes (in $) in Seychelles in 2001 to that in 2004?
Your response must be concise. 0.12. What is the ratio of the Taxes (in $) of Spain in 2001 to that in 2004?
Keep it short and to the point. 1.27. What is the ratio of the Taxes (in $) of Syrian Arab Republic in 2001 to that in 2004?
Your answer should be compact. 6.08. What is the ratio of the Taxes (in $) in United Kingdom in 2001 to that in 2004?
Your answer should be very brief. 0.84. What is the ratio of the Taxes (in $) of Seychelles in 2001 to that in 2005?
Ensure brevity in your answer.  0.11. What is the ratio of the Taxes (in $) in Spain in 2001 to that in 2005?
Provide a succinct answer. 1.15. What is the ratio of the Taxes (in $) in Syrian Arab Republic in 2001 to that in 2005?
Give a very brief answer. 4.57. What is the ratio of the Taxes (in $) in United Kingdom in 2001 to that in 2005?
Give a very brief answer. 0.83. What is the ratio of the Taxes (in $) of Seychelles in 2001 to that in 2006?
Give a very brief answer. 0.1. What is the ratio of the Taxes (in $) in Spain in 2001 to that in 2006?
Give a very brief answer. 1.07. What is the ratio of the Taxes (in $) in Syrian Arab Republic in 2001 to that in 2006?
Your answer should be compact. 2.33. What is the ratio of the Taxes (in $) in United Kingdom in 2001 to that in 2006?
Your answer should be very brief. 0.8. What is the ratio of the Taxes (in $) in Seychelles in 2001 to that in 2007?
Your answer should be compact. 0.09. What is the ratio of the Taxes (in $) of Spain in 2001 to that in 2007?
Ensure brevity in your answer.  1.14. What is the ratio of the Taxes (in $) of Syrian Arab Republic in 2001 to that in 2007?
Keep it short and to the point. 2.25. What is the ratio of the Taxes (in $) in United Kingdom in 2001 to that in 2007?
Your answer should be compact. 0.77. What is the ratio of the Taxes (in $) of Seychelles in 2002 to that in 2003?
Provide a short and direct response. 0.59. What is the ratio of the Taxes (in $) in Spain in 2002 to that in 2003?
Make the answer very short. 0.97. What is the ratio of the Taxes (in $) in Syrian Arab Republic in 2002 to that in 2003?
Your answer should be very brief. 2.14. What is the ratio of the Taxes (in $) of United Kingdom in 2002 to that in 2003?
Keep it short and to the point. 0.94. What is the ratio of the Taxes (in $) in Seychelles in 2002 to that in 2004?
Your response must be concise. 0.47. What is the ratio of the Taxes (in $) of Spain in 2002 to that in 2004?
Your answer should be very brief. 0.89. What is the ratio of the Taxes (in $) in Syrian Arab Republic in 2002 to that in 2004?
Give a very brief answer. 2.42. What is the ratio of the Taxes (in $) of United Kingdom in 2002 to that in 2004?
Give a very brief answer. 0.89. What is the ratio of the Taxes (in $) of Seychelles in 2002 to that in 2005?
Your response must be concise. 0.43. What is the ratio of the Taxes (in $) of Spain in 2002 to that in 2005?
Provide a short and direct response. 0.81. What is the ratio of the Taxes (in $) of Syrian Arab Republic in 2002 to that in 2005?
Offer a terse response. 1.82. What is the ratio of the Taxes (in $) of United Kingdom in 2002 to that in 2005?
Your response must be concise. 0.88. What is the ratio of the Taxes (in $) of Seychelles in 2002 to that in 2006?
Make the answer very short. 0.39. What is the ratio of the Taxes (in $) in Spain in 2002 to that in 2006?
Offer a very short reply. 0.76. What is the ratio of the Taxes (in $) of Syrian Arab Republic in 2002 to that in 2006?
Provide a short and direct response. 0.93. What is the ratio of the Taxes (in $) in United Kingdom in 2002 to that in 2006?
Your answer should be very brief. 0.85. What is the ratio of the Taxes (in $) in Seychelles in 2002 to that in 2007?
Ensure brevity in your answer.  0.35. What is the ratio of the Taxes (in $) of Spain in 2002 to that in 2007?
Give a very brief answer. 0.81. What is the ratio of the Taxes (in $) in Syrian Arab Republic in 2002 to that in 2007?
Your answer should be compact. 0.9. What is the ratio of the Taxes (in $) in United Kingdom in 2002 to that in 2007?
Offer a very short reply. 0.81. What is the ratio of the Taxes (in $) in Seychelles in 2003 to that in 2004?
Provide a short and direct response. 0.8. What is the ratio of the Taxes (in $) in Spain in 2003 to that in 2004?
Provide a short and direct response. 0.92. What is the ratio of the Taxes (in $) of Syrian Arab Republic in 2003 to that in 2004?
Your answer should be compact. 1.13. What is the ratio of the Taxes (in $) of United Kingdom in 2003 to that in 2004?
Offer a very short reply. 0.95. What is the ratio of the Taxes (in $) in Seychelles in 2003 to that in 2005?
Keep it short and to the point. 0.73. What is the ratio of the Taxes (in $) in Spain in 2003 to that in 2005?
Keep it short and to the point. 0.84. What is the ratio of the Taxes (in $) of Syrian Arab Republic in 2003 to that in 2005?
Ensure brevity in your answer.  0.85. What is the ratio of the Taxes (in $) in United Kingdom in 2003 to that in 2005?
Your response must be concise. 0.94. What is the ratio of the Taxes (in $) of Spain in 2003 to that in 2006?
Your answer should be very brief. 0.78. What is the ratio of the Taxes (in $) in Syrian Arab Republic in 2003 to that in 2006?
Make the answer very short. 0.43. What is the ratio of the Taxes (in $) in United Kingdom in 2003 to that in 2006?
Your answer should be very brief. 0.9. What is the ratio of the Taxes (in $) in Seychelles in 2003 to that in 2007?
Offer a terse response. 0.59. What is the ratio of the Taxes (in $) of Spain in 2003 to that in 2007?
Your response must be concise. 0.84. What is the ratio of the Taxes (in $) of Syrian Arab Republic in 2003 to that in 2007?
Make the answer very short. 0.42. What is the ratio of the Taxes (in $) in United Kingdom in 2003 to that in 2007?
Ensure brevity in your answer.  0.86. What is the ratio of the Taxes (in $) in Seychelles in 2004 to that in 2005?
Provide a short and direct response. 0.91. What is the ratio of the Taxes (in $) of Spain in 2004 to that in 2005?
Offer a terse response. 0.91. What is the ratio of the Taxes (in $) in Syrian Arab Republic in 2004 to that in 2005?
Offer a very short reply. 0.75. What is the ratio of the Taxes (in $) in Seychelles in 2004 to that in 2006?
Give a very brief answer. 0.84. What is the ratio of the Taxes (in $) of Spain in 2004 to that in 2006?
Provide a succinct answer. 0.85. What is the ratio of the Taxes (in $) in Syrian Arab Republic in 2004 to that in 2006?
Your response must be concise. 0.38. What is the ratio of the Taxes (in $) of United Kingdom in 2004 to that in 2006?
Ensure brevity in your answer.  0.95. What is the ratio of the Taxes (in $) in Seychelles in 2004 to that in 2007?
Make the answer very short. 0.74. What is the ratio of the Taxes (in $) of Spain in 2004 to that in 2007?
Give a very brief answer. 0.9. What is the ratio of the Taxes (in $) in Syrian Arab Republic in 2004 to that in 2007?
Keep it short and to the point. 0.37. What is the ratio of the Taxes (in $) in United Kingdom in 2004 to that in 2007?
Offer a very short reply. 0.91. What is the ratio of the Taxes (in $) in Seychelles in 2005 to that in 2006?
Make the answer very short. 0.92. What is the ratio of the Taxes (in $) of Spain in 2005 to that in 2006?
Ensure brevity in your answer.  0.93. What is the ratio of the Taxes (in $) of Syrian Arab Republic in 2005 to that in 2006?
Offer a very short reply. 0.51. What is the ratio of the Taxes (in $) in United Kingdom in 2005 to that in 2006?
Your response must be concise. 0.96. What is the ratio of the Taxes (in $) in Seychelles in 2005 to that in 2007?
Offer a terse response. 0.81. What is the ratio of the Taxes (in $) in Spain in 2005 to that in 2007?
Offer a terse response. 1. What is the ratio of the Taxes (in $) of Syrian Arab Republic in 2005 to that in 2007?
Offer a terse response. 0.49. What is the ratio of the Taxes (in $) of United Kingdom in 2005 to that in 2007?
Offer a terse response. 0.92. What is the ratio of the Taxes (in $) of Seychelles in 2006 to that in 2007?
Offer a very short reply. 0.89. What is the ratio of the Taxes (in $) in Spain in 2006 to that in 2007?
Ensure brevity in your answer.  1.07. What is the ratio of the Taxes (in $) in Syrian Arab Republic in 2006 to that in 2007?
Provide a short and direct response. 0.97. What is the ratio of the Taxes (in $) in United Kingdom in 2006 to that in 2007?
Your answer should be very brief. 0.95. What is the difference between the highest and the second highest Taxes (in $) in Seychelles?
Offer a very short reply. 1.06e+08. What is the difference between the highest and the second highest Taxes (in $) in Spain?
Keep it short and to the point. 2.46e+09. What is the difference between the highest and the second highest Taxes (in $) of Syrian Arab Republic?
Your answer should be compact. 4.89e+09. What is the difference between the highest and the second highest Taxes (in $) in United Kingdom?
Keep it short and to the point. 6.98e+09. What is the difference between the highest and the lowest Taxes (in $) in Seychelles?
Your answer should be compact. 8.55e+08. What is the difference between the highest and the lowest Taxes (in $) in Spain?
Your answer should be very brief. 1.54e+1. What is the difference between the highest and the lowest Taxes (in $) of Syrian Arab Republic?
Provide a short and direct response. 1.72e+1. What is the difference between the highest and the lowest Taxes (in $) of United Kingdom?
Keep it short and to the point. 3.78e+1. 